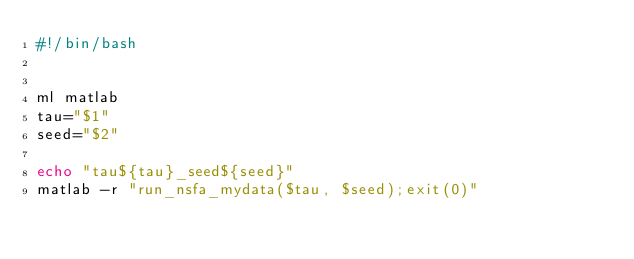Convert code to text. <code><loc_0><loc_0><loc_500><loc_500><_Bash_>#!/bin/bash


ml matlab
tau="$1"
seed="$2"

echo "tau${tau}_seed${seed}"
matlab -r "run_nsfa_mydata($tau, $seed);exit(0)"
</code> 